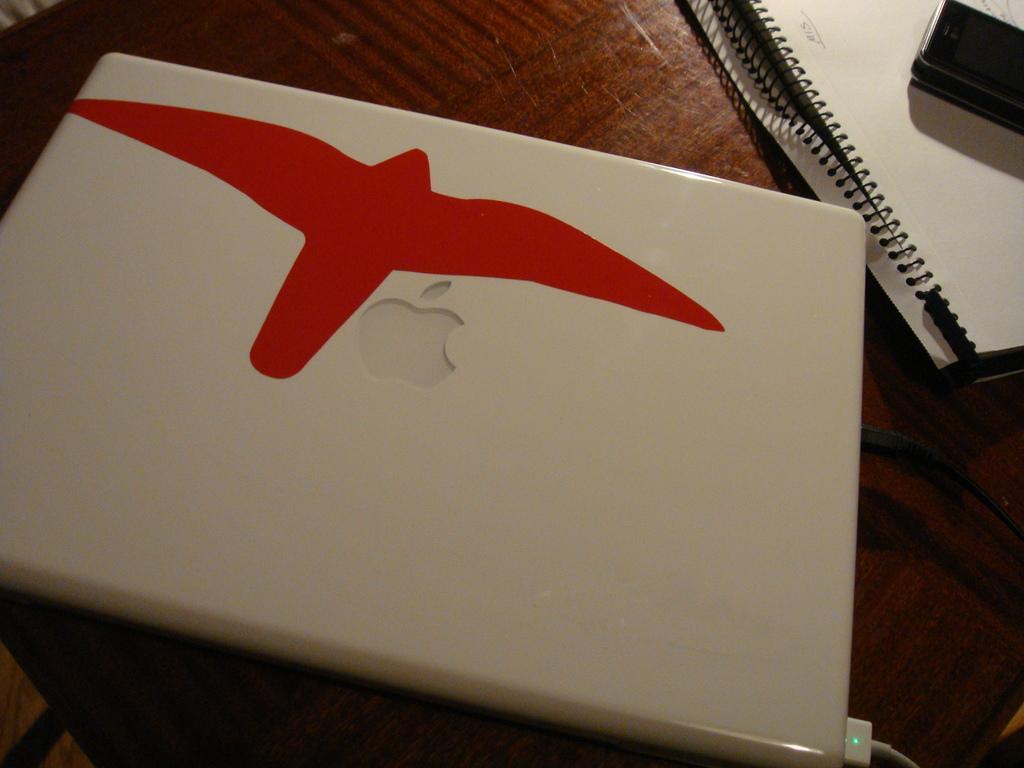Can you describe this image briefly? In the image we can see wooden surface, on the surface there is a book and on the book there is a device. There is even a laptop on the wooden surface. 